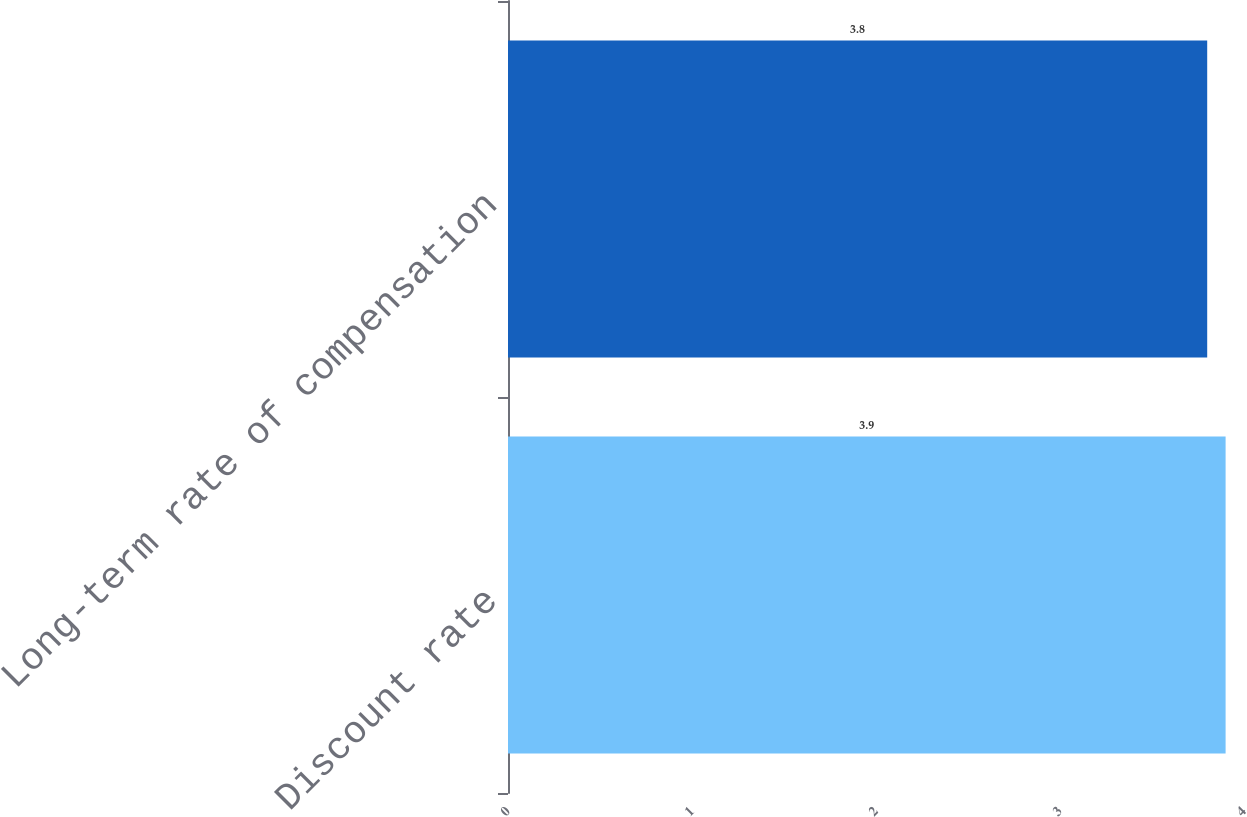Convert chart to OTSL. <chart><loc_0><loc_0><loc_500><loc_500><bar_chart><fcel>Discount rate<fcel>Long-term rate of compensation<nl><fcel>3.9<fcel>3.8<nl></chart> 